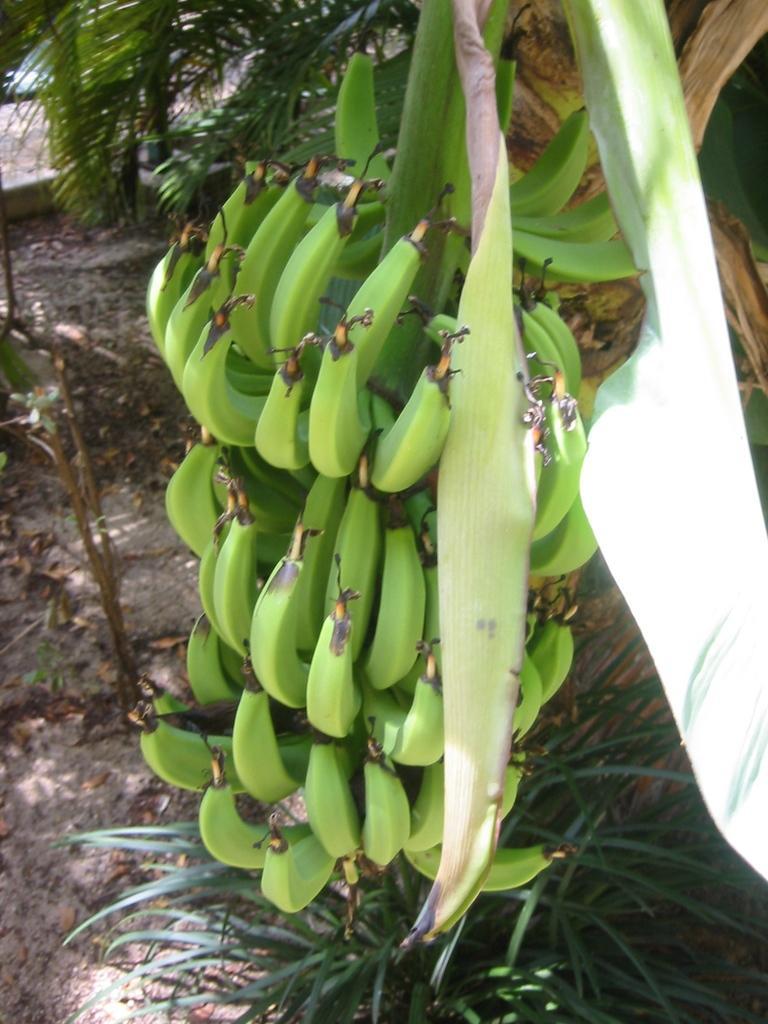Please provide a concise description of this image. In this picture there are bananas in the center of the image. 